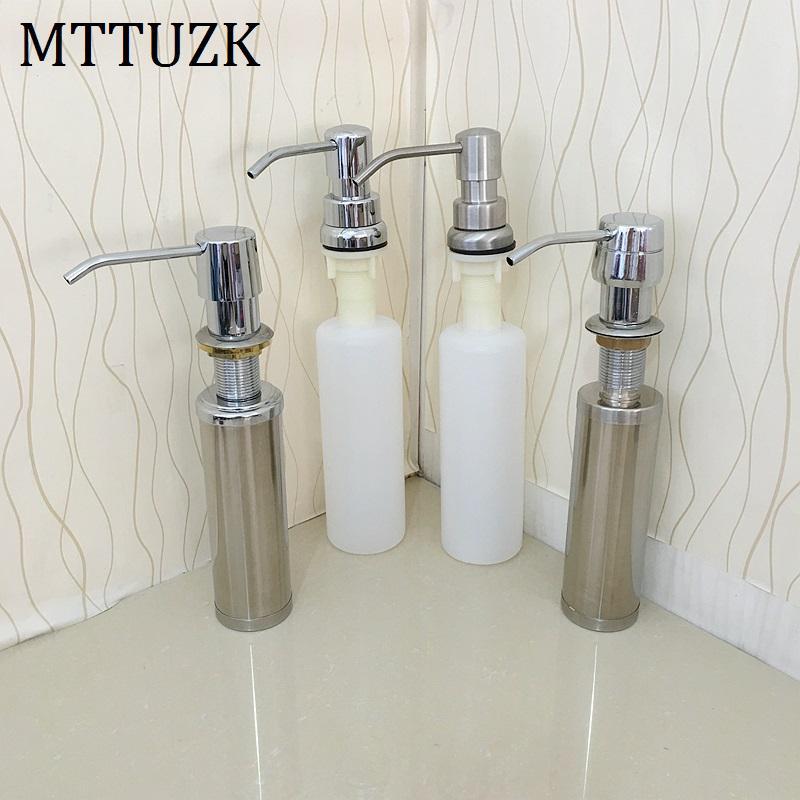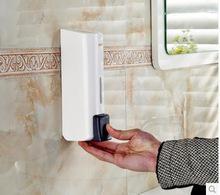The first image is the image on the left, the second image is the image on the right. For the images displayed, is the sentence "In one of the images, a person's hand is visible using a soap dispenser" factually correct? Answer yes or no. Yes. The first image is the image on the left, the second image is the image on the right. Considering the images on both sides, is "a human hand is dispensing soap" valid? Answer yes or no. Yes. 